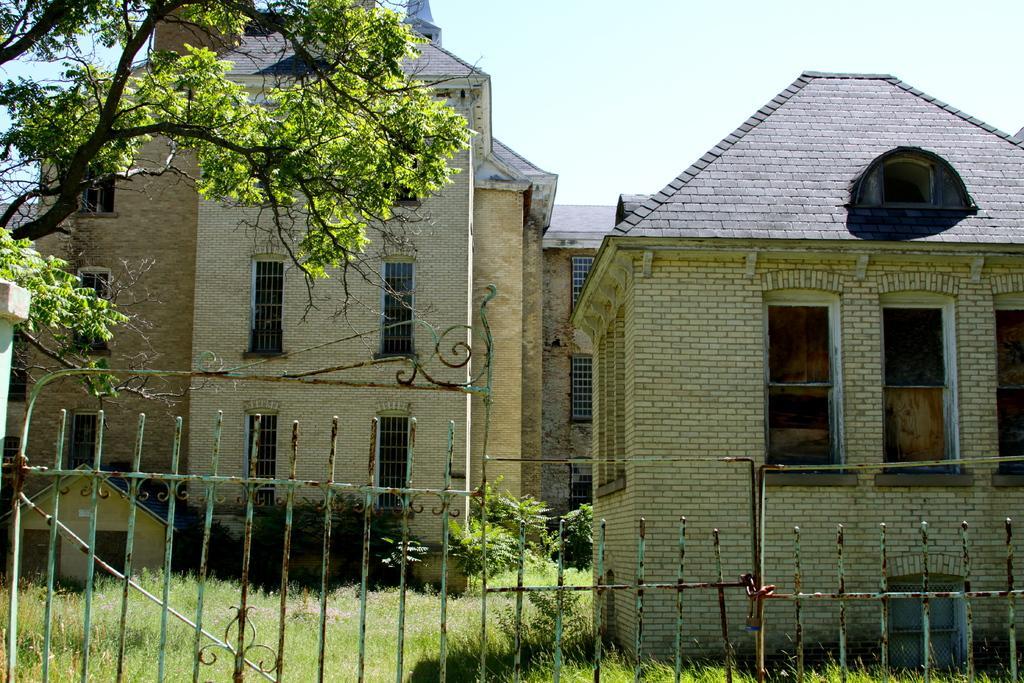Please provide a concise description of this image. In the center of the image we can see the sky, buildings, windows, plants, one tree with branches and leaves, grass and a fence. 